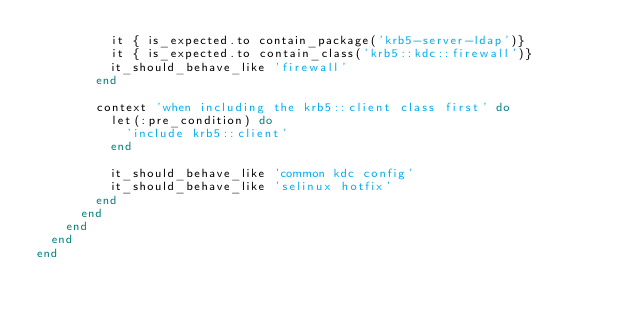Convert code to text. <code><loc_0><loc_0><loc_500><loc_500><_Ruby_>          it { is_expected.to contain_package('krb5-server-ldap')}
          it { is_expected.to contain_class('krb5::kdc::firewall')}
          it_should_behave_like 'firewall'
        end

        context 'when including the krb5::client class first' do
          let(:pre_condition) do
            'include krb5::client'
          end

          it_should_behave_like 'common kdc config'
          it_should_behave_like 'selinux hotfix'
        end
      end
    end
  end
end
</code> 